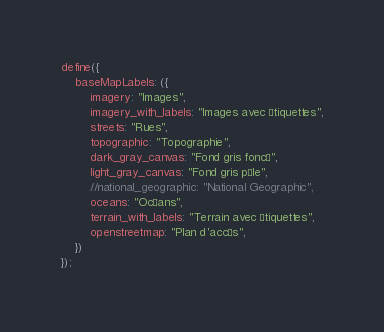Convert code to text. <code><loc_0><loc_0><loc_500><loc_500><_JavaScript_>define({
    baseMapLabels: ({
        imagery: "Images",
        imagery_with_labels: "Images avec étiquettes",
        streets: "Rues",
        topographic: "Topographie",
        dark_gray_canvas: "Fond gris foncé",
        light_gray_canvas: "Fond gris pâle",
        //national_geographic: "National Geographic",
        oceans: "Océans",
        terrain_with_labels: "Terrain avec étiquettes",
        openstreetmap: "Plan d'accès",
    })
});
</code> 